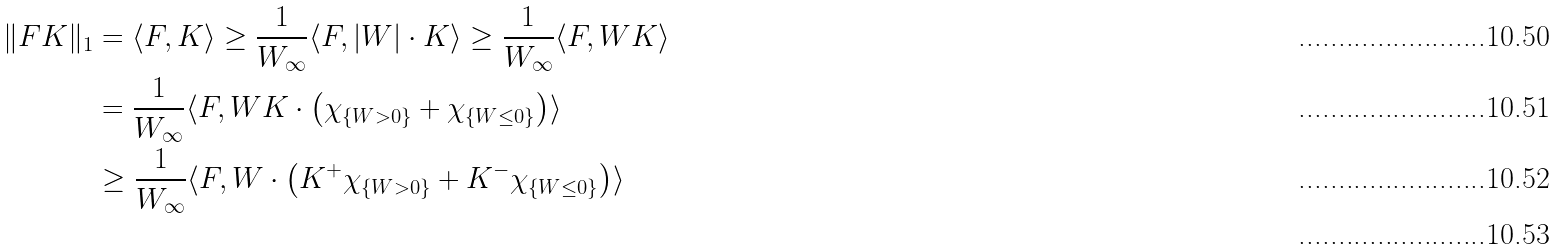Convert formula to latex. <formula><loc_0><loc_0><loc_500><loc_500>\| F K \| _ { 1 } & = \langle F , K \rangle \geq \frac { 1 } { W _ { \infty } } \langle F , | W | \cdot K \rangle \geq \frac { 1 } { W _ { \infty } } \langle F , W K \rangle \\ & = \frac { 1 } { W _ { \infty } } \langle F , W K \cdot \left ( \chi _ { \{ W > 0 \} } + \chi _ { \{ W \leq 0 \} } \right ) \rangle \\ & \geq \frac { 1 } { W _ { \infty } } \langle F , W \cdot \left ( K ^ { + } \chi _ { \{ W > 0 \} } + K ^ { - } \chi _ { \{ W \leq 0 \} } \right ) \rangle \\</formula> 